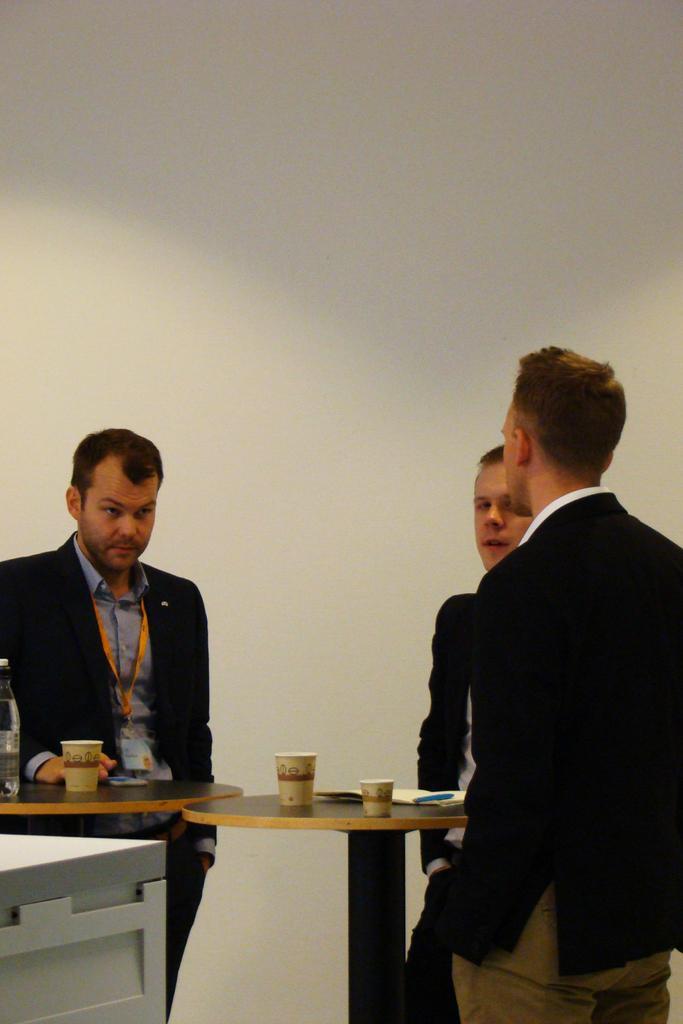Can you describe this image briefly? In this image I can see three persons standing beside the table. There are some glasses, one bottle are placed. In the background I can see a wall. The three persons are wearing black color suit. 